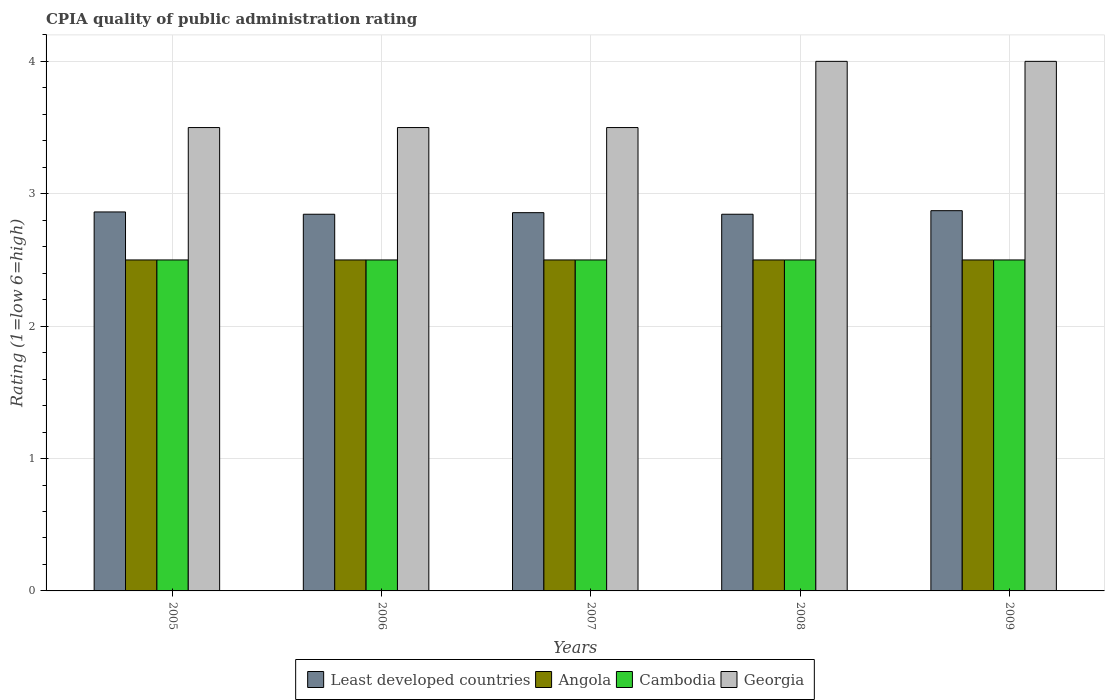Are the number of bars per tick equal to the number of legend labels?
Your response must be concise. Yes. Are the number of bars on each tick of the X-axis equal?
Offer a very short reply. Yes. What is the label of the 1st group of bars from the left?
Give a very brief answer. 2005. What is the CPIA rating in Georgia in 2008?
Provide a succinct answer. 4. Across all years, what is the maximum CPIA rating in Cambodia?
Your answer should be very brief. 2.5. Across all years, what is the minimum CPIA rating in Cambodia?
Your answer should be very brief. 2.5. In which year was the CPIA rating in Least developed countries maximum?
Ensure brevity in your answer.  2009. In which year was the CPIA rating in Angola minimum?
Ensure brevity in your answer.  2005. What is the total CPIA rating in Least developed countries in the graph?
Provide a succinct answer. 14.28. What is the difference between the CPIA rating in Angola in 2005 and that in 2007?
Your answer should be compact. 0. What is the difference between the CPIA rating in Angola in 2005 and the CPIA rating in Least developed countries in 2006?
Ensure brevity in your answer.  -0.35. What is the ratio of the CPIA rating in Least developed countries in 2005 to that in 2008?
Ensure brevity in your answer.  1.01. Is the CPIA rating in Georgia in 2007 less than that in 2008?
Offer a terse response. Yes. What is the difference between the highest and the second highest CPIA rating in Angola?
Give a very brief answer. 0. What is the difference between the highest and the lowest CPIA rating in Georgia?
Offer a terse response. 0.5. In how many years, is the CPIA rating in Cambodia greater than the average CPIA rating in Cambodia taken over all years?
Your answer should be compact. 0. What does the 1st bar from the left in 2007 represents?
Provide a succinct answer. Least developed countries. What does the 2nd bar from the right in 2006 represents?
Your answer should be very brief. Cambodia. Is it the case that in every year, the sum of the CPIA rating in Angola and CPIA rating in Georgia is greater than the CPIA rating in Least developed countries?
Your answer should be compact. Yes. How many bars are there?
Your response must be concise. 20. Are all the bars in the graph horizontal?
Your answer should be very brief. No. How many years are there in the graph?
Make the answer very short. 5. What is the difference between two consecutive major ticks on the Y-axis?
Give a very brief answer. 1. Are the values on the major ticks of Y-axis written in scientific E-notation?
Offer a very short reply. No. Does the graph contain any zero values?
Ensure brevity in your answer.  No. Does the graph contain grids?
Give a very brief answer. Yes. How are the legend labels stacked?
Ensure brevity in your answer.  Horizontal. What is the title of the graph?
Your answer should be compact. CPIA quality of public administration rating. What is the label or title of the X-axis?
Ensure brevity in your answer.  Years. What is the label or title of the Y-axis?
Provide a succinct answer. Rating (1=low 6=high). What is the Rating (1=low 6=high) of Least developed countries in 2005?
Your answer should be compact. 2.86. What is the Rating (1=low 6=high) in Angola in 2005?
Your answer should be compact. 2.5. What is the Rating (1=low 6=high) of Least developed countries in 2006?
Provide a short and direct response. 2.85. What is the Rating (1=low 6=high) of Angola in 2006?
Your response must be concise. 2.5. What is the Rating (1=low 6=high) in Cambodia in 2006?
Provide a short and direct response. 2.5. What is the Rating (1=low 6=high) in Least developed countries in 2007?
Your answer should be compact. 2.86. What is the Rating (1=low 6=high) of Angola in 2007?
Give a very brief answer. 2.5. What is the Rating (1=low 6=high) of Least developed countries in 2008?
Provide a succinct answer. 2.85. What is the Rating (1=low 6=high) of Angola in 2008?
Provide a short and direct response. 2.5. What is the Rating (1=low 6=high) in Least developed countries in 2009?
Offer a terse response. 2.87. What is the Rating (1=low 6=high) of Angola in 2009?
Give a very brief answer. 2.5. What is the Rating (1=low 6=high) in Georgia in 2009?
Provide a succinct answer. 4. Across all years, what is the maximum Rating (1=low 6=high) in Least developed countries?
Your answer should be compact. 2.87. Across all years, what is the maximum Rating (1=low 6=high) in Cambodia?
Your answer should be very brief. 2.5. Across all years, what is the maximum Rating (1=low 6=high) of Georgia?
Your response must be concise. 4. Across all years, what is the minimum Rating (1=low 6=high) in Least developed countries?
Your response must be concise. 2.85. Across all years, what is the minimum Rating (1=low 6=high) of Angola?
Your answer should be very brief. 2.5. Across all years, what is the minimum Rating (1=low 6=high) in Georgia?
Make the answer very short. 3.5. What is the total Rating (1=low 6=high) of Least developed countries in the graph?
Your answer should be compact. 14.28. What is the total Rating (1=low 6=high) in Angola in the graph?
Your answer should be compact. 12.5. What is the total Rating (1=low 6=high) in Cambodia in the graph?
Your response must be concise. 12.5. What is the total Rating (1=low 6=high) in Georgia in the graph?
Offer a very short reply. 18.5. What is the difference between the Rating (1=low 6=high) of Least developed countries in 2005 and that in 2006?
Ensure brevity in your answer.  0.02. What is the difference between the Rating (1=low 6=high) of Cambodia in 2005 and that in 2006?
Offer a very short reply. 0. What is the difference between the Rating (1=low 6=high) in Least developed countries in 2005 and that in 2007?
Ensure brevity in your answer.  0.01. What is the difference between the Rating (1=low 6=high) of Angola in 2005 and that in 2007?
Provide a short and direct response. 0. What is the difference between the Rating (1=low 6=high) in Cambodia in 2005 and that in 2007?
Give a very brief answer. 0. What is the difference between the Rating (1=low 6=high) of Georgia in 2005 and that in 2007?
Make the answer very short. 0. What is the difference between the Rating (1=low 6=high) in Least developed countries in 2005 and that in 2008?
Make the answer very short. 0.02. What is the difference between the Rating (1=low 6=high) in Angola in 2005 and that in 2008?
Give a very brief answer. 0. What is the difference between the Rating (1=low 6=high) of Cambodia in 2005 and that in 2008?
Give a very brief answer. 0. What is the difference between the Rating (1=low 6=high) in Least developed countries in 2005 and that in 2009?
Keep it short and to the point. -0.01. What is the difference between the Rating (1=low 6=high) in Angola in 2005 and that in 2009?
Ensure brevity in your answer.  0. What is the difference between the Rating (1=low 6=high) of Cambodia in 2005 and that in 2009?
Provide a short and direct response. 0. What is the difference between the Rating (1=low 6=high) of Least developed countries in 2006 and that in 2007?
Make the answer very short. -0.01. What is the difference between the Rating (1=low 6=high) in Angola in 2006 and that in 2008?
Give a very brief answer. 0. What is the difference between the Rating (1=low 6=high) in Georgia in 2006 and that in 2008?
Keep it short and to the point. -0.5. What is the difference between the Rating (1=low 6=high) of Least developed countries in 2006 and that in 2009?
Your response must be concise. -0.03. What is the difference between the Rating (1=low 6=high) of Georgia in 2006 and that in 2009?
Keep it short and to the point. -0.5. What is the difference between the Rating (1=low 6=high) in Least developed countries in 2007 and that in 2008?
Your response must be concise. 0.01. What is the difference between the Rating (1=low 6=high) of Angola in 2007 and that in 2008?
Offer a terse response. 0. What is the difference between the Rating (1=low 6=high) in Least developed countries in 2007 and that in 2009?
Provide a short and direct response. -0.01. What is the difference between the Rating (1=low 6=high) of Angola in 2007 and that in 2009?
Provide a succinct answer. 0. What is the difference between the Rating (1=low 6=high) of Cambodia in 2007 and that in 2009?
Make the answer very short. 0. What is the difference between the Rating (1=low 6=high) in Least developed countries in 2008 and that in 2009?
Your response must be concise. -0.03. What is the difference between the Rating (1=low 6=high) of Least developed countries in 2005 and the Rating (1=low 6=high) of Angola in 2006?
Give a very brief answer. 0.36. What is the difference between the Rating (1=low 6=high) in Least developed countries in 2005 and the Rating (1=low 6=high) in Cambodia in 2006?
Your answer should be compact. 0.36. What is the difference between the Rating (1=low 6=high) in Least developed countries in 2005 and the Rating (1=low 6=high) in Georgia in 2006?
Your answer should be very brief. -0.64. What is the difference between the Rating (1=low 6=high) of Angola in 2005 and the Rating (1=low 6=high) of Cambodia in 2006?
Provide a succinct answer. 0. What is the difference between the Rating (1=low 6=high) in Angola in 2005 and the Rating (1=low 6=high) in Georgia in 2006?
Give a very brief answer. -1. What is the difference between the Rating (1=low 6=high) of Least developed countries in 2005 and the Rating (1=low 6=high) of Angola in 2007?
Provide a succinct answer. 0.36. What is the difference between the Rating (1=low 6=high) of Least developed countries in 2005 and the Rating (1=low 6=high) of Cambodia in 2007?
Offer a very short reply. 0.36. What is the difference between the Rating (1=low 6=high) of Least developed countries in 2005 and the Rating (1=low 6=high) of Georgia in 2007?
Offer a very short reply. -0.64. What is the difference between the Rating (1=low 6=high) of Angola in 2005 and the Rating (1=low 6=high) of Cambodia in 2007?
Ensure brevity in your answer.  0. What is the difference between the Rating (1=low 6=high) in Angola in 2005 and the Rating (1=low 6=high) in Georgia in 2007?
Make the answer very short. -1. What is the difference between the Rating (1=low 6=high) of Cambodia in 2005 and the Rating (1=low 6=high) of Georgia in 2007?
Provide a short and direct response. -1. What is the difference between the Rating (1=low 6=high) of Least developed countries in 2005 and the Rating (1=low 6=high) of Angola in 2008?
Ensure brevity in your answer.  0.36. What is the difference between the Rating (1=low 6=high) of Least developed countries in 2005 and the Rating (1=low 6=high) of Cambodia in 2008?
Your answer should be very brief. 0.36. What is the difference between the Rating (1=low 6=high) in Least developed countries in 2005 and the Rating (1=low 6=high) in Georgia in 2008?
Provide a short and direct response. -1.14. What is the difference between the Rating (1=low 6=high) in Angola in 2005 and the Rating (1=low 6=high) in Cambodia in 2008?
Give a very brief answer. 0. What is the difference between the Rating (1=low 6=high) in Angola in 2005 and the Rating (1=low 6=high) in Georgia in 2008?
Keep it short and to the point. -1.5. What is the difference between the Rating (1=low 6=high) of Cambodia in 2005 and the Rating (1=low 6=high) of Georgia in 2008?
Give a very brief answer. -1.5. What is the difference between the Rating (1=low 6=high) of Least developed countries in 2005 and the Rating (1=low 6=high) of Angola in 2009?
Ensure brevity in your answer.  0.36. What is the difference between the Rating (1=low 6=high) in Least developed countries in 2005 and the Rating (1=low 6=high) in Cambodia in 2009?
Provide a short and direct response. 0.36. What is the difference between the Rating (1=low 6=high) of Least developed countries in 2005 and the Rating (1=low 6=high) of Georgia in 2009?
Your answer should be compact. -1.14. What is the difference between the Rating (1=low 6=high) in Angola in 2005 and the Rating (1=low 6=high) in Cambodia in 2009?
Your answer should be very brief. 0. What is the difference between the Rating (1=low 6=high) of Angola in 2005 and the Rating (1=low 6=high) of Georgia in 2009?
Offer a terse response. -1.5. What is the difference between the Rating (1=low 6=high) of Cambodia in 2005 and the Rating (1=low 6=high) of Georgia in 2009?
Give a very brief answer. -1.5. What is the difference between the Rating (1=low 6=high) in Least developed countries in 2006 and the Rating (1=low 6=high) in Angola in 2007?
Make the answer very short. 0.35. What is the difference between the Rating (1=low 6=high) in Least developed countries in 2006 and the Rating (1=low 6=high) in Cambodia in 2007?
Your answer should be very brief. 0.35. What is the difference between the Rating (1=low 6=high) of Least developed countries in 2006 and the Rating (1=low 6=high) of Georgia in 2007?
Provide a succinct answer. -0.65. What is the difference between the Rating (1=low 6=high) of Cambodia in 2006 and the Rating (1=low 6=high) of Georgia in 2007?
Provide a succinct answer. -1. What is the difference between the Rating (1=low 6=high) of Least developed countries in 2006 and the Rating (1=low 6=high) of Angola in 2008?
Give a very brief answer. 0.35. What is the difference between the Rating (1=low 6=high) in Least developed countries in 2006 and the Rating (1=low 6=high) in Cambodia in 2008?
Offer a terse response. 0.35. What is the difference between the Rating (1=low 6=high) in Least developed countries in 2006 and the Rating (1=low 6=high) in Georgia in 2008?
Provide a succinct answer. -1.15. What is the difference between the Rating (1=low 6=high) in Cambodia in 2006 and the Rating (1=low 6=high) in Georgia in 2008?
Give a very brief answer. -1.5. What is the difference between the Rating (1=low 6=high) of Least developed countries in 2006 and the Rating (1=low 6=high) of Angola in 2009?
Your answer should be compact. 0.35. What is the difference between the Rating (1=low 6=high) of Least developed countries in 2006 and the Rating (1=low 6=high) of Cambodia in 2009?
Ensure brevity in your answer.  0.35. What is the difference between the Rating (1=low 6=high) in Least developed countries in 2006 and the Rating (1=low 6=high) in Georgia in 2009?
Provide a short and direct response. -1.15. What is the difference between the Rating (1=low 6=high) in Least developed countries in 2007 and the Rating (1=low 6=high) in Angola in 2008?
Your answer should be compact. 0.36. What is the difference between the Rating (1=low 6=high) in Least developed countries in 2007 and the Rating (1=low 6=high) in Cambodia in 2008?
Make the answer very short. 0.36. What is the difference between the Rating (1=low 6=high) in Least developed countries in 2007 and the Rating (1=low 6=high) in Georgia in 2008?
Offer a terse response. -1.14. What is the difference between the Rating (1=low 6=high) in Cambodia in 2007 and the Rating (1=low 6=high) in Georgia in 2008?
Your response must be concise. -1.5. What is the difference between the Rating (1=low 6=high) in Least developed countries in 2007 and the Rating (1=low 6=high) in Angola in 2009?
Give a very brief answer. 0.36. What is the difference between the Rating (1=low 6=high) in Least developed countries in 2007 and the Rating (1=low 6=high) in Cambodia in 2009?
Ensure brevity in your answer.  0.36. What is the difference between the Rating (1=low 6=high) in Least developed countries in 2007 and the Rating (1=low 6=high) in Georgia in 2009?
Provide a succinct answer. -1.14. What is the difference between the Rating (1=low 6=high) in Cambodia in 2007 and the Rating (1=low 6=high) in Georgia in 2009?
Provide a short and direct response. -1.5. What is the difference between the Rating (1=low 6=high) in Least developed countries in 2008 and the Rating (1=low 6=high) in Angola in 2009?
Ensure brevity in your answer.  0.35. What is the difference between the Rating (1=low 6=high) in Least developed countries in 2008 and the Rating (1=low 6=high) in Cambodia in 2009?
Ensure brevity in your answer.  0.35. What is the difference between the Rating (1=low 6=high) in Least developed countries in 2008 and the Rating (1=low 6=high) in Georgia in 2009?
Offer a terse response. -1.15. What is the difference between the Rating (1=low 6=high) of Angola in 2008 and the Rating (1=low 6=high) of Georgia in 2009?
Make the answer very short. -1.5. What is the average Rating (1=low 6=high) of Least developed countries per year?
Make the answer very short. 2.86. What is the average Rating (1=low 6=high) in Angola per year?
Make the answer very short. 2.5. What is the average Rating (1=low 6=high) in Georgia per year?
Keep it short and to the point. 3.7. In the year 2005, what is the difference between the Rating (1=low 6=high) of Least developed countries and Rating (1=low 6=high) of Angola?
Offer a terse response. 0.36. In the year 2005, what is the difference between the Rating (1=low 6=high) in Least developed countries and Rating (1=low 6=high) in Cambodia?
Provide a succinct answer. 0.36. In the year 2005, what is the difference between the Rating (1=low 6=high) of Least developed countries and Rating (1=low 6=high) of Georgia?
Offer a terse response. -0.64. In the year 2005, what is the difference between the Rating (1=low 6=high) of Angola and Rating (1=low 6=high) of Georgia?
Make the answer very short. -1. In the year 2006, what is the difference between the Rating (1=low 6=high) of Least developed countries and Rating (1=low 6=high) of Angola?
Give a very brief answer. 0.35. In the year 2006, what is the difference between the Rating (1=low 6=high) in Least developed countries and Rating (1=low 6=high) in Cambodia?
Offer a terse response. 0.35. In the year 2006, what is the difference between the Rating (1=low 6=high) of Least developed countries and Rating (1=low 6=high) of Georgia?
Your response must be concise. -0.65. In the year 2006, what is the difference between the Rating (1=low 6=high) of Angola and Rating (1=low 6=high) of Georgia?
Keep it short and to the point. -1. In the year 2006, what is the difference between the Rating (1=low 6=high) in Cambodia and Rating (1=low 6=high) in Georgia?
Ensure brevity in your answer.  -1. In the year 2007, what is the difference between the Rating (1=low 6=high) of Least developed countries and Rating (1=low 6=high) of Angola?
Keep it short and to the point. 0.36. In the year 2007, what is the difference between the Rating (1=low 6=high) in Least developed countries and Rating (1=low 6=high) in Cambodia?
Ensure brevity in your answer.  0.36. In the year 2007, what is the difference between the Rating (1=low 6=high) in Least developed countries and Rating (1=low 6=high) in Georgia?
Make the answer very short. -0.64. In the year 2007, what is the difference between the Rating (1=low 6=high) in Angola and Rating (1=low 6=high) in Cambodia?
Give a very brief answer. 0. In the year 2007, what is the difference between the Rating (1=low 6=high) in Angola and Rating (1=low 6=high) in Georgia?
Your answer should be very brief. -1. In the year 2007, what is the difference between the Rating (1=low 6=high) in Cambodia and Rating (1=low 6=high) in Georgia?
Give a very brief answer. -1. In the year 2008, what is the difference between the Rating (1=low 6=high) in Least developed countries and Rating (1=low 6=high) in Angola?
Offer a terse response. 0.35. In the year 2008, what is the difference between the Rating (1=low 6=high) in Least developed countries and Rating (1=low 6=high) in Cambodia?
Your answer should be compact. 0.35. In the year 2008, what is the difference between the Rating (1=low 6=high) of Least developed countries and Rating (1=low 6=high) of Georgia?
Give a very brief answer. -1.15. In the year 2008, what is the difference between the Rating (1=low 6=high) in Angola and Rating (1=low 6=high) in Cambodia?
Your answer should be very brief. 0. In the year 2008, what is the difference between the Rating (1=low 6=high) in Angola and Rating (1=low 6=high) in Georgia?
Ensure brevity in your answer.  -1.5. In the year 2008, what is the difference between the Rating (1=low 6=high) in Cambodia and Rating (1=low 6=high) in Georgia?
Make the answer very short. -1.5. In the year 2009, what is the difference between the Rating (1=low 6=high) of Least developed countries and Rating (1=low 6=high) of Angola?
Your answer should be very brief. 0.37. In the year 2009, what is the difference between the Rating (1=low 6=high) in Least developed countries and Rating (1=low 6=high) in Cambodia?
Your response must be concise. 0.37. In the year 2009, what is the difference between the Rating (1=low 6=high) of Least developed countries and Rating (1=low 6=high) of Georgia?
Offer a terse response. -1.13. In the year 2009, what is the difference between the Rating (1=low 6=high) in Cambodia and Rating (1=low 6=high) in Georgia?
Offer a terse response. -1.5. What is the ratio of the Rating (1=low 6=high) of Cambodia in 2005 to that in 2006?
Provide a succinct answer. 1. What is the ratio of the Rating (1=low 6=high) of Angola in 2005 to that in 2007?
Give a very brief answer. 1. What is the ratio of the Rating (1=low 6=high) in Cambodia in 2005 to that in 2007?
Offer a very short reply. 1. What is the ratio of the Rating (1=low 6=high) in Least developed countries in 2005 to that in 2008?
Provide a short and direct response. 1.01. What is the ratio of the Rating (1=low 6=high) in Least developed countries in 2005 to that in 2009?
Make the answer very short. 1. What is the ratio of the Rating (1=low 6=high) of Least developed countries in 2006 to that in 2007?
Your answer should be compact. 1. What is the ratio of the Rating (1=low 6=high) in Georgia in 2006 to that in 2007?
Ensure brevity in your answer.  1. What is the ratio of the Rating (1=low 6=high) of Least developed countries in 2006 to that in 2008?
Your answer should be very brief. 1. What is the ratio of the Rating (1=low 6=high) in Angola in 2006 to that in 2008?
Your response must be concise. 1. What is the ratio of the Rating (1=low 6=high) of Cambodia in 2006 to that in 2008?
Provide a short and direct response. 1. What is the ratio of the Rating (1=low 6=high) of Georgia in 2006 to that in 2008?
Offer a terse response. 0.88. What is the ratio of the Rating (1=low 6=high) in Least developed countries in 2006 to that in 2009?
Your answer should be compact. 0.99. What is the ratio of the Rating (1=low 6=high) of Cambodia in 2007 to that in 2008?
Offer a very short reply. 1. What is the ratio of the Rating (1=low 6=high) of Georgia in 2007 to that in 2008?
Keep it short and to the point. 0.88. What is the ratio of the Rating (1=low 6=high) of Angola in 2007 to that in 2009?
Ensure brevity in your answer.  1. What is the ratio of the Rating (1=low 6=high) of Cambodia in 2007 to that in 2009?
Your answer should be very brief. 1. What is the ratio of the Rating (1=low 6=high) in Georgia in 2007 to that in 2009?
Your answer should be compact. 0.88. What is the ratio of the Rating (1=low 6=high) in Least developed countries in 2008 to that in 2009?
Offer a terse response. 0.99. What is the ratio of the Rating (1=low 6=high) of Angola in 2008 to that in 2009?
Provide a succinct answer. 1. What is the ratio of the Rating (1=low 6=high) in Cambodia in 2008 to that in 2009?
Your answer should be compact. 1. What is the difference between the highest and the second highest Rating (1=low 6=high) of Least developed countries?
Offer a terse response. 0.01. What is the difference between the highest and the second highest Rating (1=low 6=high) in Georgia?
Your answer should be compact. 0. What is the difference between the highest and the lowest Rating (1=low 6=high) in Least developed countries?
Offer a very short reply. 0.03. What is the difference between the highest and the lowest Rating (1=low 6=high) of Cambodia?
Offer a very short reply. 0. What is the difference between the highest and the lowest Rating (1=low 6=high) of Georgia?
Ensure brevity in your answer.  0.5. 